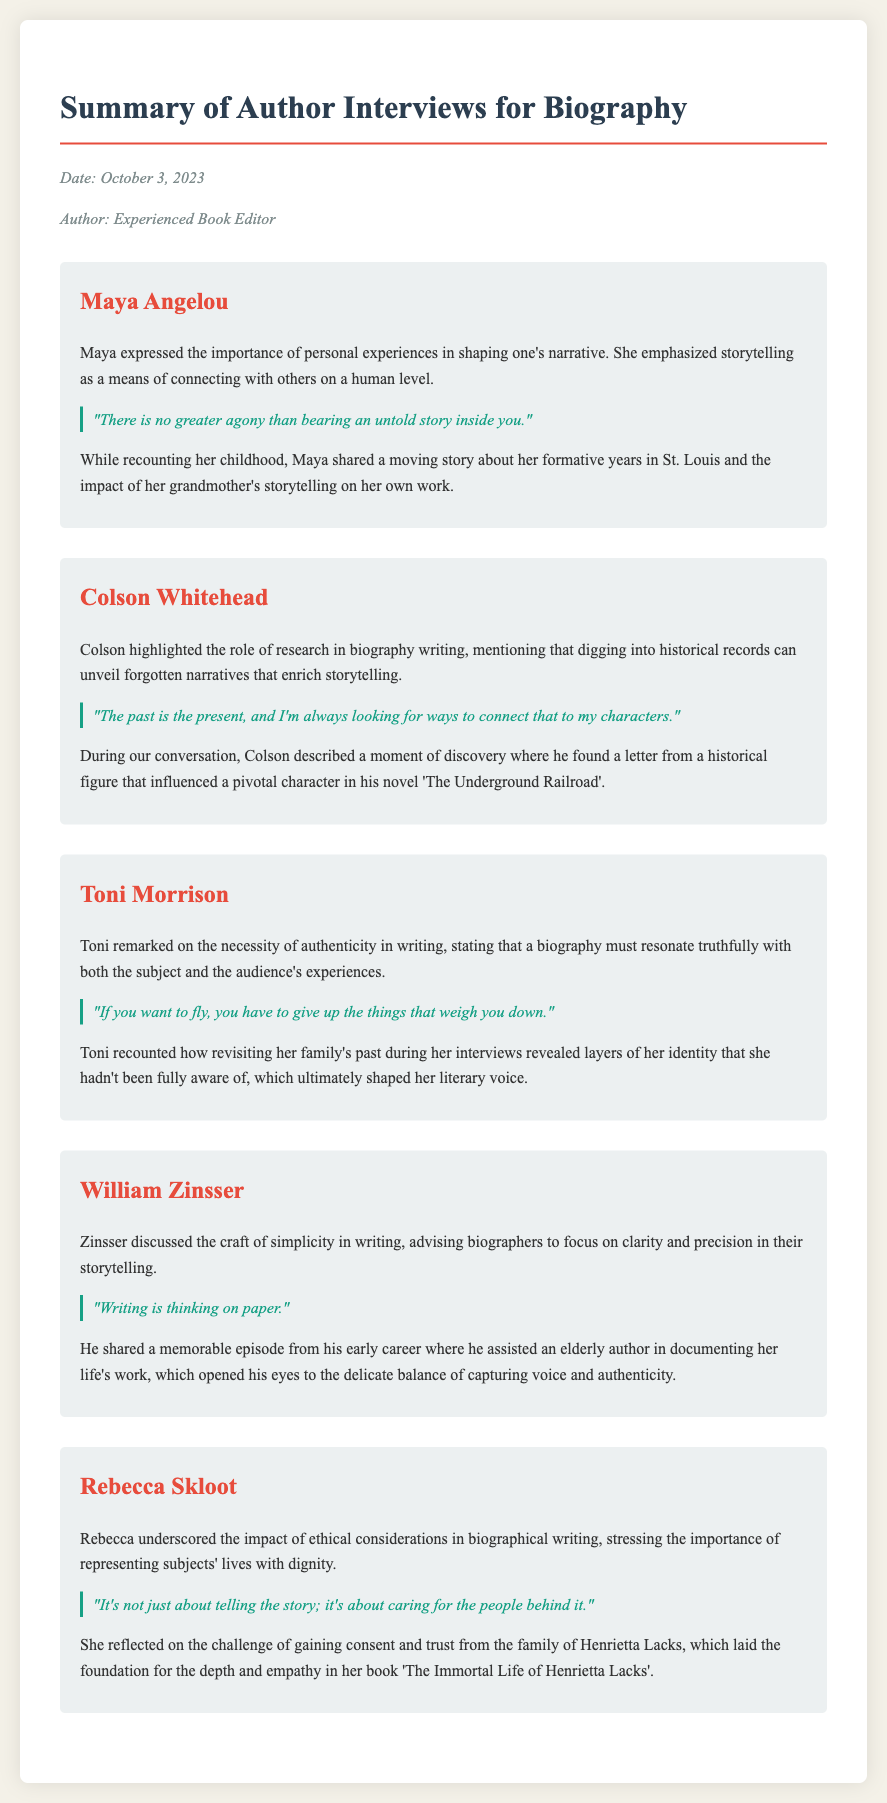What is the date of the memo? The date is mentioned in the meta section of the document.
Answer: October 3, 2023 Who is the author of the memo? The author is also listed in the meta section of the document.
Answer: Experienced Book Editor What is the quote attributed to Maya Angelou? Each interview includes a distinct quote from the author being discussed.
Answer: "There is no greater agony than bearing an untold story inside you." Which author discussed the importance of ethical considerations? The insights highlight key themes or points made by each author.
Answer: Rebecca Skloot What craft advice did William Zinsser provide? The insights summarize each author's perspective on biography writing.
Answer: Simplicity in writing Which author shared an anecdote about documenting an elderly author's work? Each interview section includes a specific anecdote contributed by the author.
Answer: William Zinsser What impact did Toni Morrison mention in relation to authenticity? This question is about the insight shared by Morrison on authenticity.
Answer: Necessity of authenticity What historical figure's letter influenced Colson Whitehead's writing? The anecdote from Colson references a significant moment in his research.
Answer: A historical figure (specific name not mentioned) What was the main insight shared by Maya Angelou? Each author provides insights that reflect their experiences and wisdom.
Answer: Importance of personal experiences 